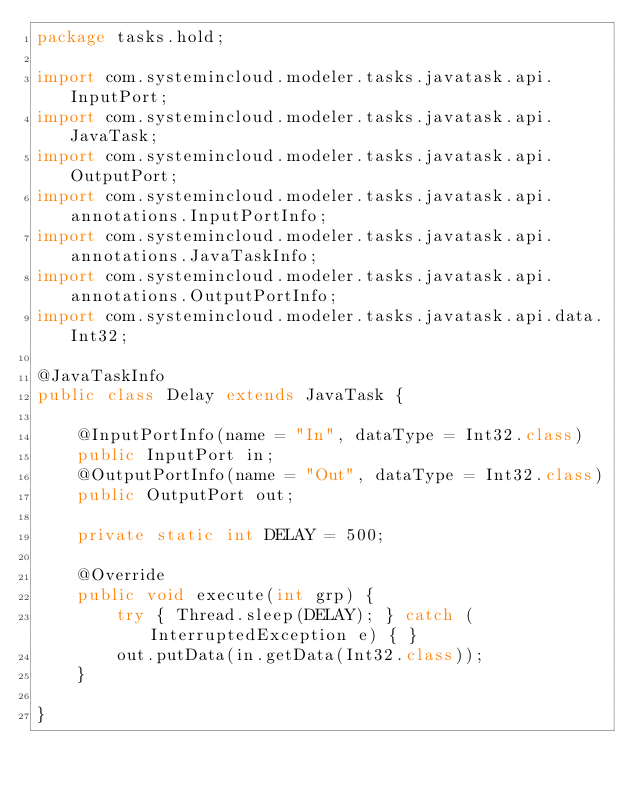Convert code to text. <code><loc_0><loc_0><loc_500><loc_500><_Java_>package tasks.hold;

import com.systemincloud.modeler.tasks.javatask.api.InputPort;
import com.systemincloud.modeler.tasks.javatask.api.JavaTask;
import com.systemincloud.modeler.tasks.javatask.api.OutputPort;
import com.systemincloud.modeler.tasks.javatask.api.annotations.InputPortInfo;
import com.systemincloud.modeler.tasks.javatask.api.annotations.JavaTaskInfo;
import com.systemincloud.modeler.tasks.javatask.api.annotations.OutputPortInfo;
import com.systemincloud.modeler.tasks.javatask.api.data.Int32;

@JavaTaskInfo
public class Delay extends JavaTask {

	@InputPortInfo(name = "In", dataType = Int32.class)
	public InputPort in;
	@OutputPortInfo(name = "Out", dataType = Int32.class)
	public OutputPort out;

	private static int DELAY = 500;
	
	@Override
	public void execute(int grp) {
		try { Thread.sleep(DELAY); } catch (InterruptedException e) { }
		out.putData(in.getData(Int32.class));
	}

}
</code> 